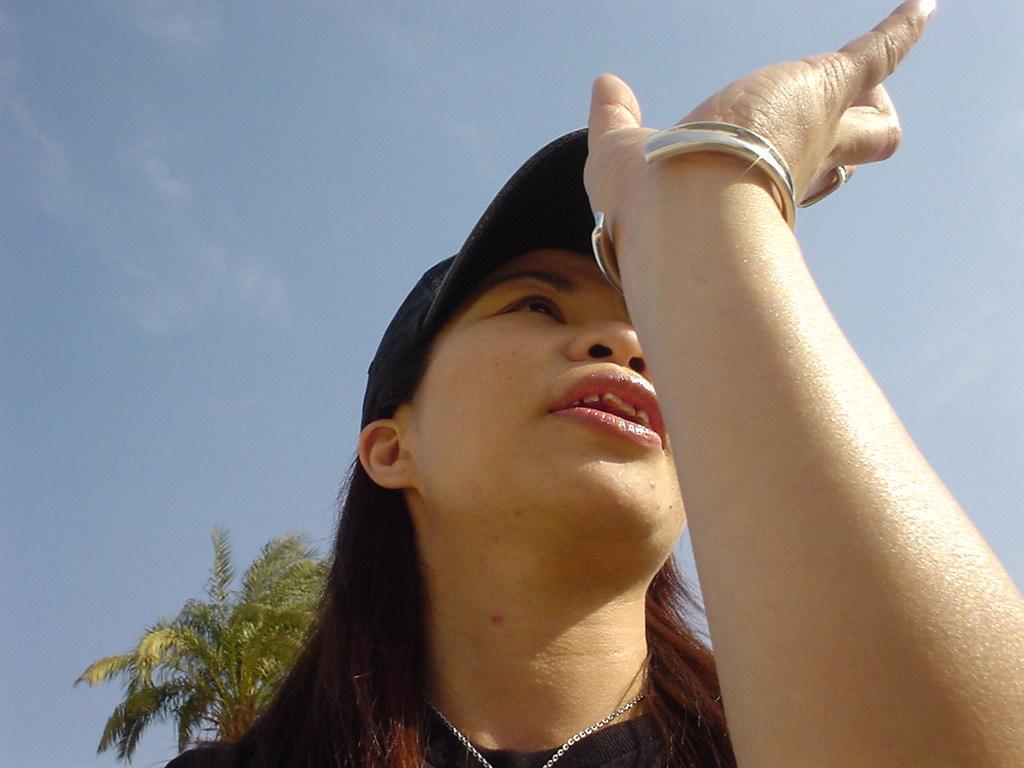Can you describe this image briefly? This woman wore a cap. Sky is in blue color. Far there is a tree. 